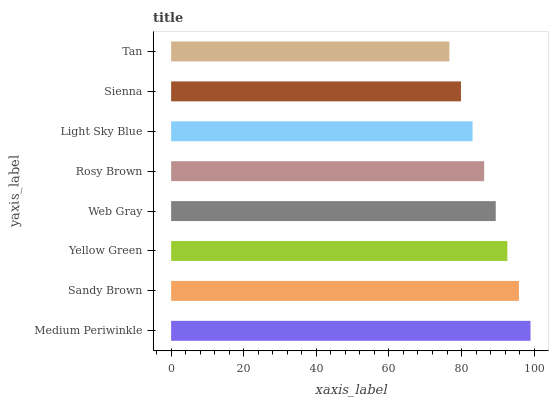Is Tan the minimum?
Answer yes or no. Yes. Is Medium Periwinkle the maximum?
Answer yes or no. Yes. Is Sandy Brown the minimum?
Answer yes or no. No. Is Sandy Brown the maximum?
Answer yes or no. No. Is Medium Periwinkle greater than Sandy Brown?
Answer yes or no. Yes. Is Sandy Brown less than Medium Periwinkle?
Answer yes or no. Yes. Is Sandy Brown greater than Medium Periwinkle?
Answer yes or no. No. Is Medium Periwinkle less than Sandy Brown?
Answer yes or no. No. Is Web Gray the high median?
Answer yes or no. Yes. Is Rosy Brown the low median?
Answer yes or no. Yes. Is Tan the high median?
Answer yes or no. No. Is Medium Periwinkle the low median?
Answer yes or no. No. 